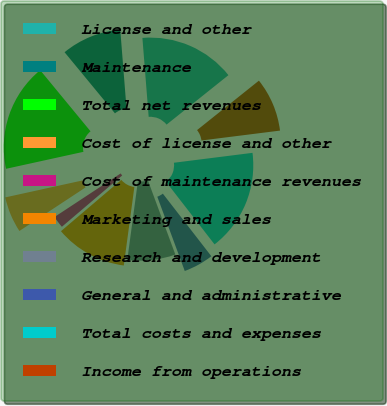Convert chart. <chart><loc_0><loc_0><loc_500><loc_500><pie_chart><fcel>License and other<fcel>Maintenance<fcel>Total net revenues<fcel>Cost of license and other<fcel>Cost of maintenance revenues<fcel>Marketing and sales<fcel>Research and development<fcel>General and administrative<fcel>Total costs and expenses<fcel>Income from operations<nl><fcel>15.53%<fcel>9.71%<fcel>17.47%<fcel>5.83%<fcel>1.95%<fcel>11.65%<fcel>7.77%<fcel>4.86%<fcel>16.5%<fcel>8.74%<nl></chart> 